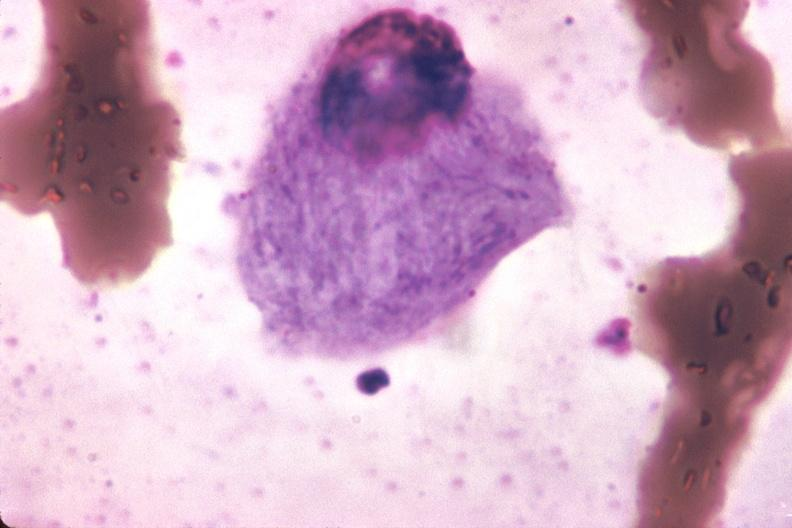what is present?
Answer the question using a single word or phrase. Gaucher cell 